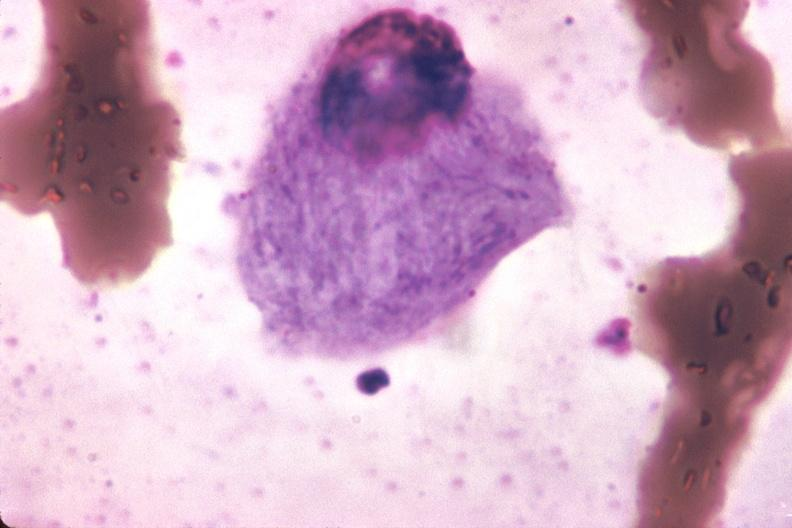what is present?
Answer the question using a single word or phrase. Gaucher cell 